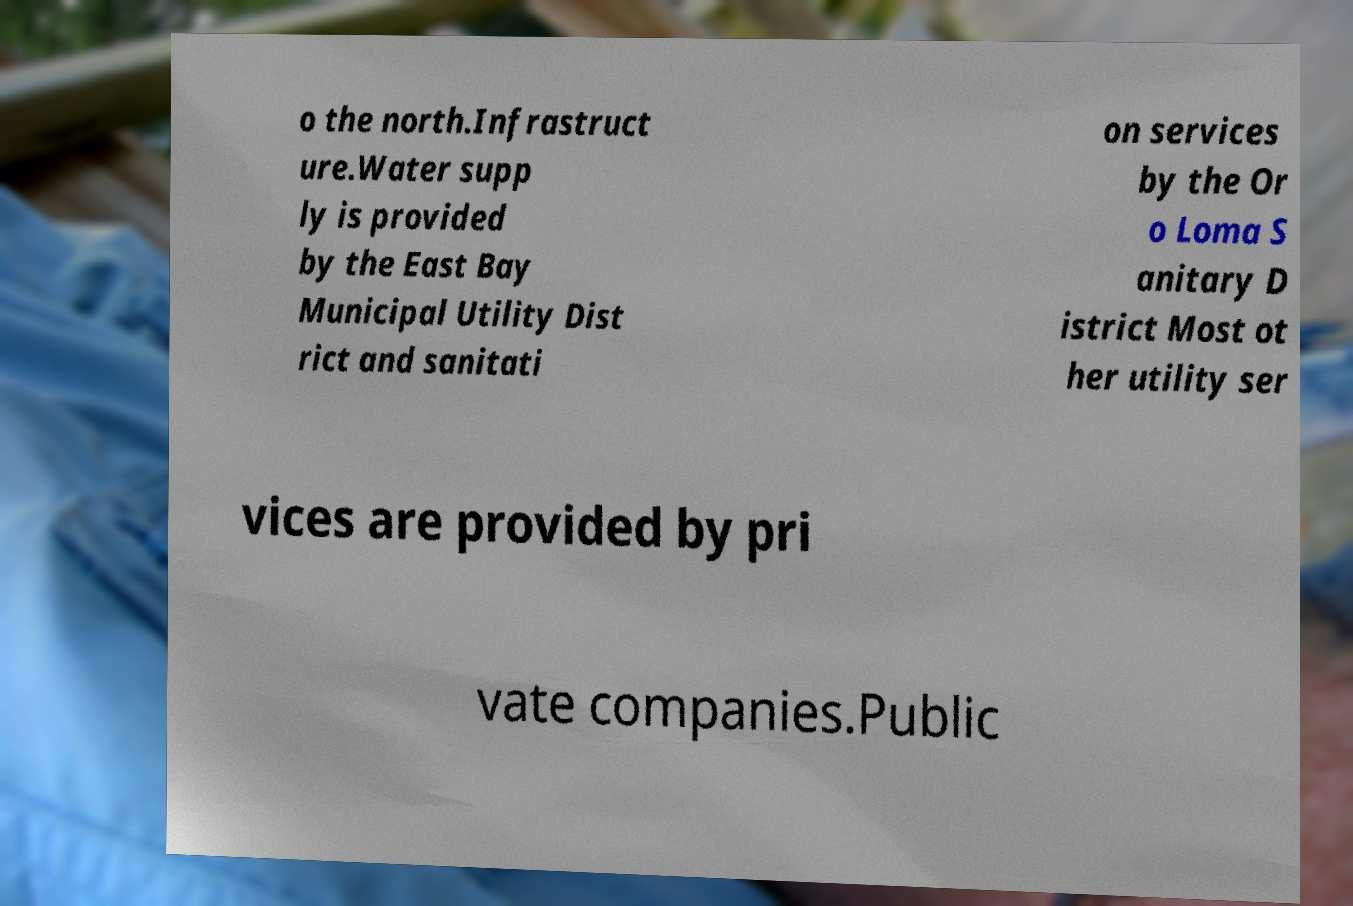Can you accurately transcribe the text from the provided image for me? o the north.Infrastruct ure.Water supp ly is provided by the East Bay Municipal Utility Dist rict and sanitati on services by the Or o Loma S anitary D istrict Most ot her utility ser vices are provided by pri vate companies.Public 